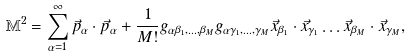Convert formula to latex. <formula><loc_0><loc_0><loc_500><loc_500>\mathbb { M } ^ { 2 } = \sum _ { \alpha = 1 } ^ { \infty } { \vec { p } _ { \alpha } \cdot \vec { p } _ { \alpha } + \frac { 1 } { M ! } g _ { \alpha \beta _ { 1 } , \dots , \beta _ { M } } g _ { \alpha \gamma _ { 1 } , \dots , \gamma _ { M } } \vec { x } _ { \beta _ { 1 } } \cdot \vec { x } _ { \gamma _ { 1 } } \dots \vec { x } _ { \beta _ { M } } \cdot \vec { x } _ { \gamma _ { M } } } ,</formula> 